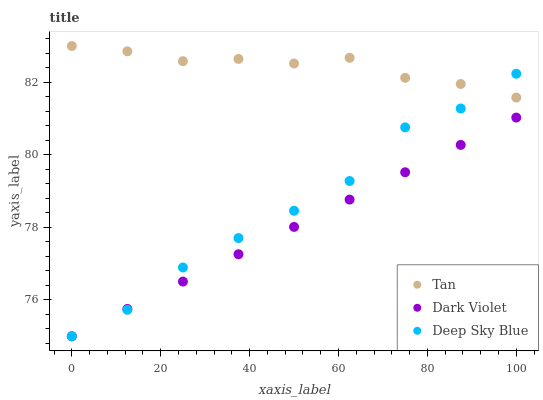Does Dark Violet have the minimum area under the curve?
Answer yes or no. Yes. Does Tan have the maximum area under the curve?
Answer yes or no. Yes. Does Deep Sky Blue have the minimum area under the curve?
Answer yes or no. No. Does Deep Sky Blue have the maximum area under the curve?
Answer yes or no. No. Is Dark Violet the smoothest?
Answer yes or no. Yes. Is Deep Sky Blue the roughest?
Answer yes or no. Yes. Is Deep Sky Blue the smoothest?
Answer yes or no. No. Is Dark Violet the roughest?
Answer yes or no. No. Does Deep Sky Blue have the lowest value?
Answer yes or no. Yes. Does Tan have the highest value?
Answer yes or no. Yes. Does Deep Sky Blue have the highest value?
Answer yes or no. No. Is Dark Violet less than Tan?
Answer yes or no. Yes. Is Tan greater than Dark Violet?
Answer yes or no. Yes. Does Deep Sky Blue intersect Dark Violet?
Answer yes or no. Yes. Is Deep Sky Blue less than Dark Violet?
Answer yes or no. No. Is Deep Sky Blue greater than Dark Violet?
Answer yes or no. No. Does Dark Violet intersect Tan?
Answer yes or no. No. 